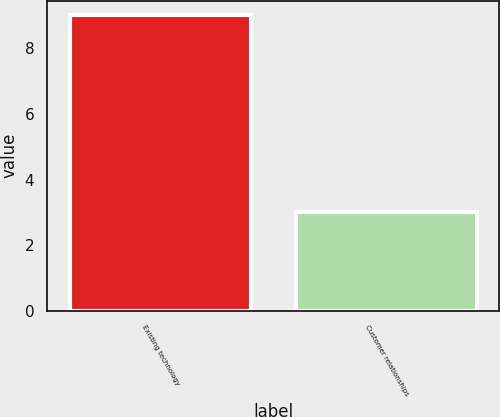<chart> <loc_0><loc_0><loc_500><loc_500><bar_chart><fcel>Existing technology<fcel>Customer relationships<nl><fcel>9<fcel>3<nl></chart> 